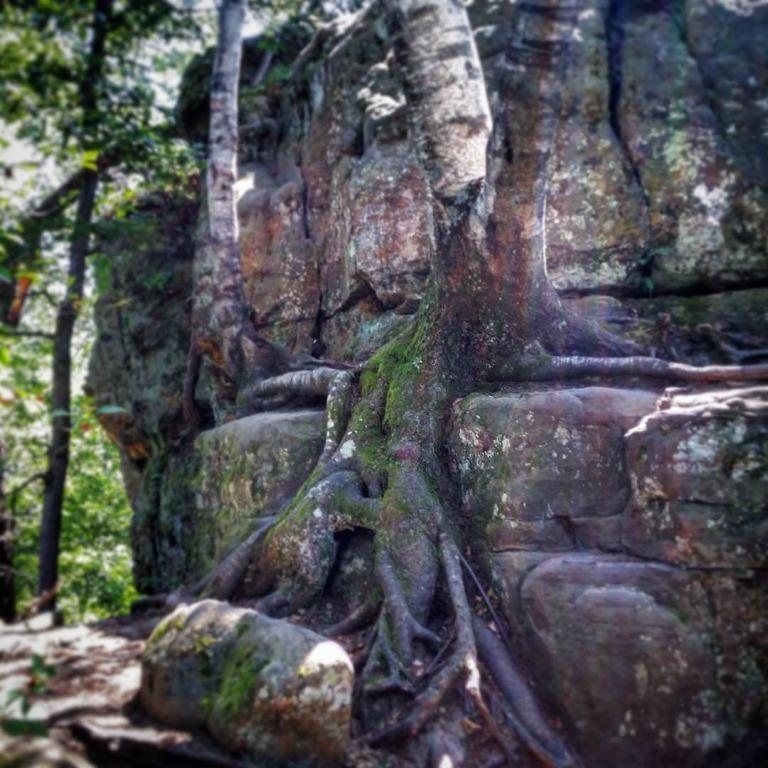What type of natural objects can be seen in the image? There are tree trunks and rocks in the image. Where are the trees located in the image? The trees are in the left corner of the image. What type of request can be seen written on the rocks in the image? There is no request written on the rocks in the image; the rocks are simply natural objects in the scene. 